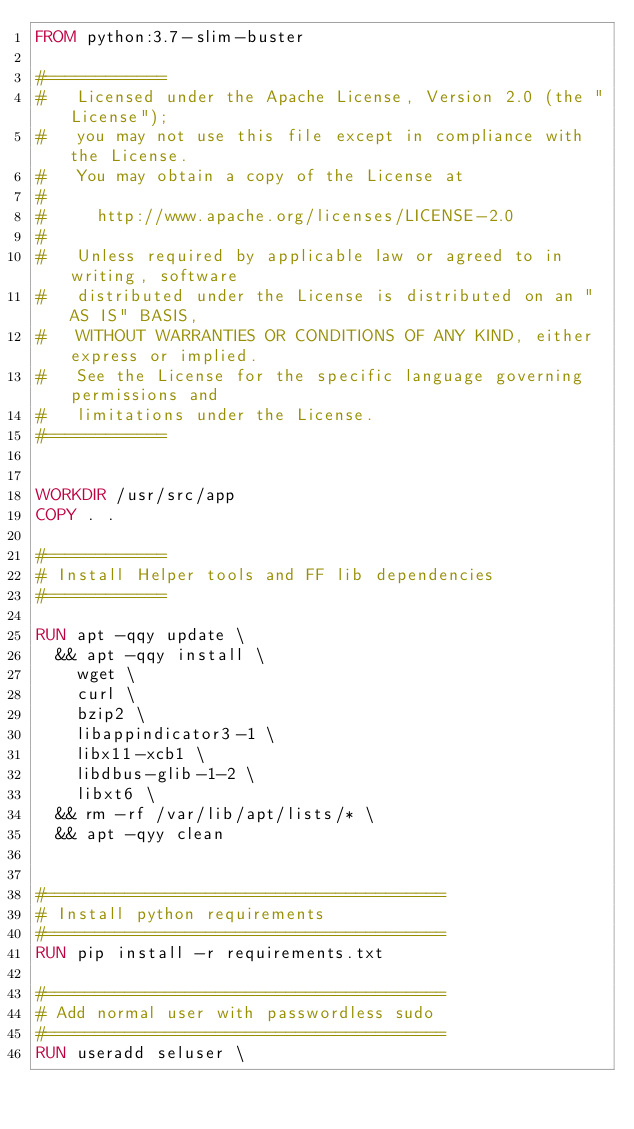Convert code to text. <code><loc_0><loc_0><loc_500><loc_500><_Dockerfile_>FROM python:3.7-slim-buster

#============
#   Licensed under the Apache License, Version 2.0 (the "License");
#   you may not use this file except in compliance with the License.
#   You may obtain a copy of the License at
#
#     http://www.apache.org/licenses/LICENSE-2.0
#
#   Unless required by applicable law or agreed to in writing, software
#   distributed under the License is distributed on an "AS IS" BASIS,
#   WITHOUT WARRANTIES OR CONDITIONS OF ANY KIND, either express or implied.
#   See the License for the specific language governing permissions and
#   limitations under the License.
#============


WORKDIR /usr/src/app
COPY . .

#============
# Install Helper tools and FF lib dependencies
#============

RUN apt -qqy update \
  && apt -qqy install \
    wget \
    curl \
    bzip2 \
    libappindicator3-1 \
    libx11-xcb1 \
    libdbus-glib-1-2 \
    libxt6 \
  && rm -rf /var/lib/apt/lists/* \
  && apt -qyy clean


#========================================
# Install python requirements
#========================================
RUN pip install -r requirements.txt

#========================================
# Add normal user with passwordless sudo
#========================================
RUN useradd seluser \</code> 